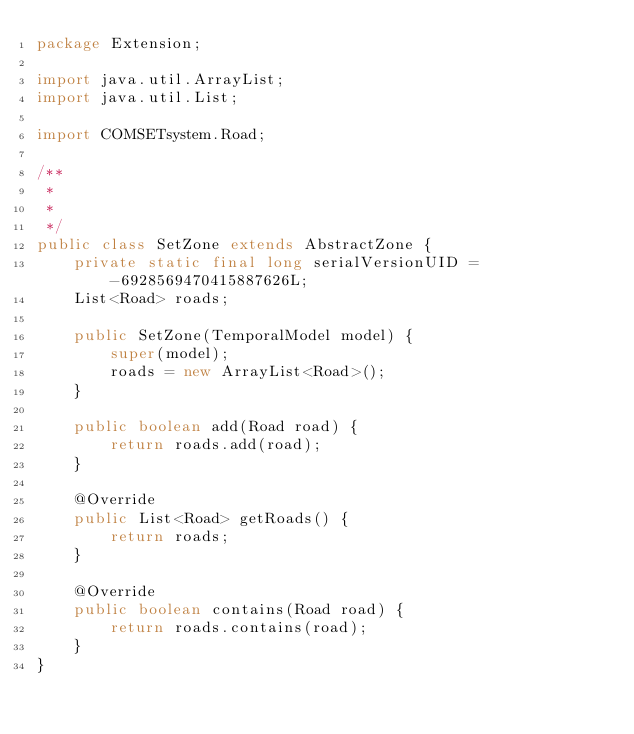Convert code to text. <code><loc_0><loc_0><loc_500><loc_500><_Java_>package Extension;

import java.util.ArrayList;
import java.util.List;

import COMSETsystem.Road;

/**
 * 
 *
 */
public class SetZone extends AbstractZone {
	private static final long serialVersionUID = -6928569470415887626L;
	List<Road> roads;

	public SetZone(TemporalModel model) {
		super(model);
		roads = new ArrayList<Road>();
	}

	public boolean add(Road road) {
		return roads.add(road);
	}

	@Override
	public List<Road> getRoads() {
		return roads;
	}

	@Override
	public boolean contains(Road road) {
		return roads.contains(road);
	}
}
</code> 